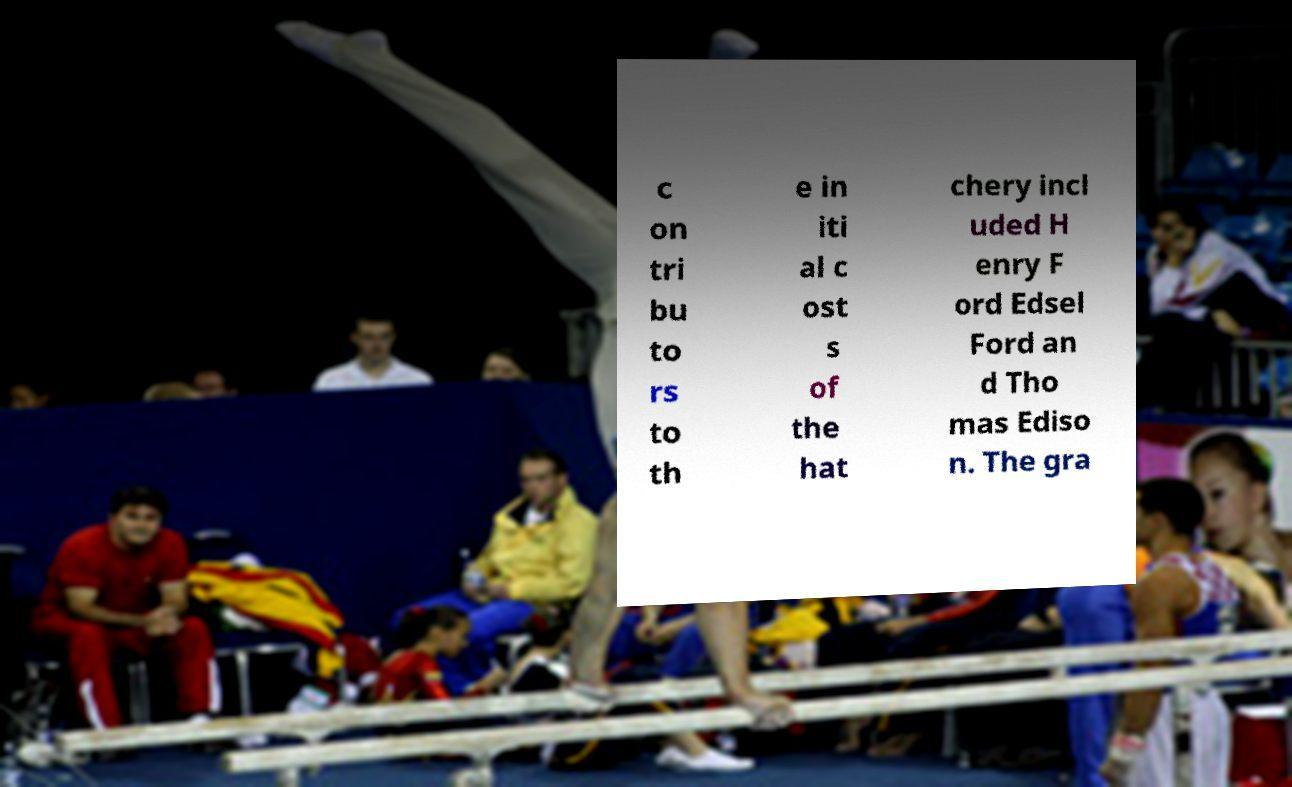Can you accurately transcribe the text from the provided image for me? c on tri bu to rs to th e in iti al c ost s of the hat chery incl uded H enry F ord Edsel Ford an d Tho mas Ediso n. The gra 